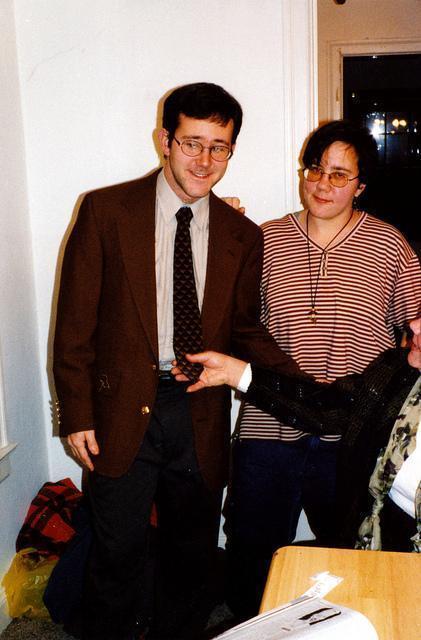What is sometimes substituted for the item the woman is holding?
Pick the correct solution from the four options below to address the question.
Options: Cummerbund, glove, sock, bow tie. Bow tie. 